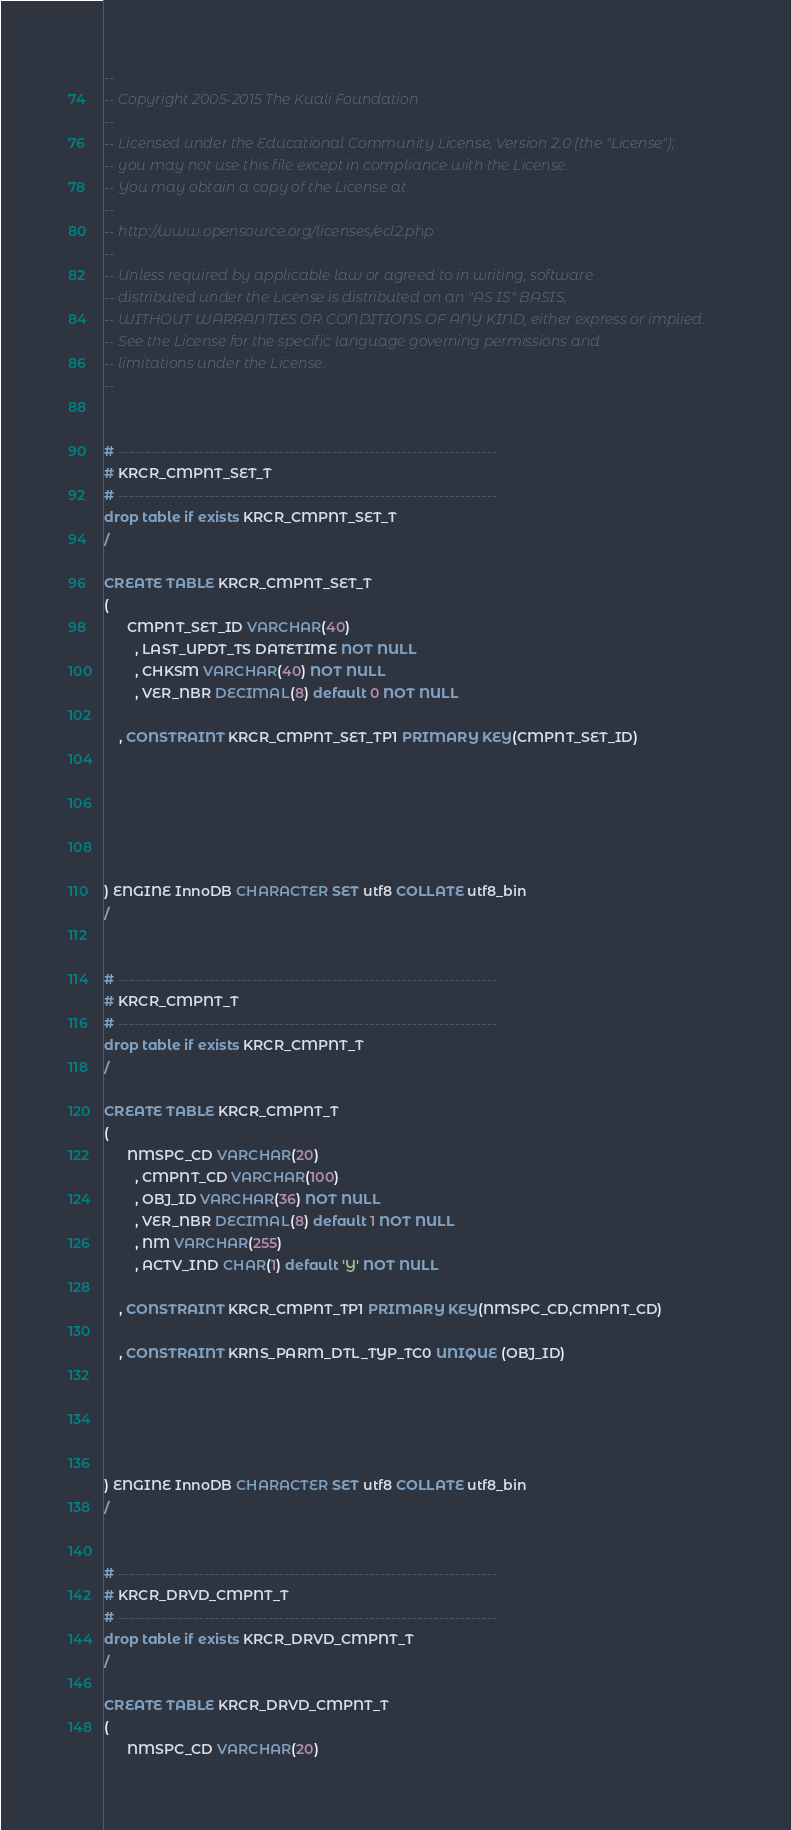<code> <loc_0><loc_0><loc_500><loc_500><_SQL_>--
-- Copyright 2005-2015 The Kuali Foundation
--
-- Licensed under the Educational Community License, Version 2.0 (the "License");
-- you may not use this file except in compliance with the License.
-- You may obtain a copy of the License at
--
-- http://www.opensource.org/licenses/ecl2.php
--
-- Unless required by applicable law or agreed to in writing, software
-- distributed under the License is distributed on an "AS IS" BASIS,
-- WITHOUT WARRANTIES OR CONDITIONS OF ANY KIND, either express or implied.
-- See the License for the specific language governing permissions and
-- limitations under the License.
--


# -----------------------------------------------------------------------
# KRCR_CMPNT_SET_T
# -----------------------------------------------------------------------
drop table if exists KRCR_CMPNT_SET_T
/

CREATE TABLE KRCR_CMPNT_SET_T
(
      CMPNT_SET_ID VARCHAR(40)
        , LAST_UPDT_TS DATETIME NOT NULL
        , CHKSM VARCHAR(40) NOT NULL
        , VER_NBR DECIMAL(8) default 0 NOT NULL
    
    , CONSTRAINT KRCR_CMPNT_SET_TP1 PRIMARY KEY(CMPNT_SET_ID)






) ENGINE InnoDB CHARACTER SET utf8 COLLATE utf8_bin
/


# -----------------------------------------------------------------------
# KRCR_CMPNT_T
# -----------------------------------------------------------------------
drop table if exists KRCR_CMPNT_T
/

CREATE TABLE KRCR_CMPNT_T
(
      NMSPC_CD VARCHAR(20)
        , CMPNT_CD VARCHAR(100)
        , OBJ_ID VARCHAR(36) NOT NULL
        , VER_NBR DECIMAL(8) default 1 NOT NULL
        , NM VARCHAR(255)
        , ACTV_IND CHAR(1) default 'Y' NOT NULL
    
    , CONSTRAINT KRCR_CMPNT_TP1 PRIMARY KEY(NMSPC_CD,CMPNT_CD)

    , CONSTRAINT KRNS_PARM_DTL_TYP_TC0 UNIQUE (OBJ_ID)





) ENGINE InnoDB CHARACTER SET utf8 COLLATE utf8_bin
/


# -----------------------------------------------------------------------
# KRCR_DRVD_CMPNT_T
# -----------------------------------------------------------------------
drop table if exists KRCR_DRVD_CMPNT_T
/

CREATE TABLE KRCR_DRVD_CMPNT_T
(
      NMSPC_CD VARCHAR(20)</code> 